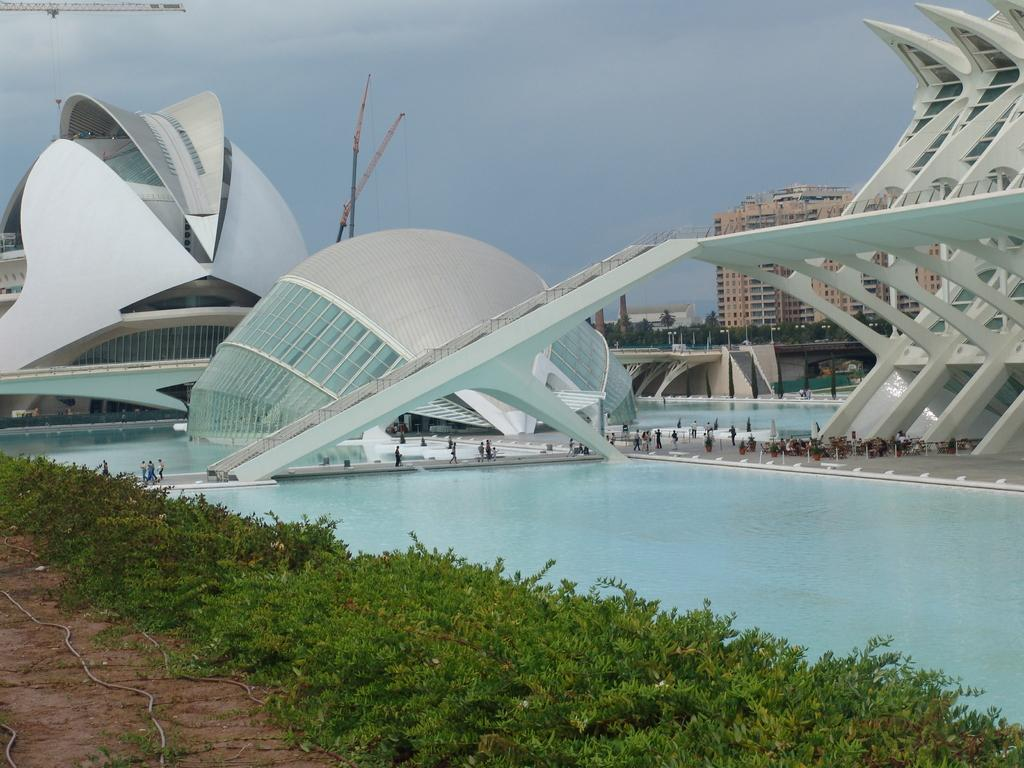What type of water feature can be seen in the image? There is a pool in the image. What kind of structures are visible in the image? The image contains beautiful architecture. What is located on the left side of the image? There is land on the left side of the image. What type of vegetation can be seen on the left side of the image? Plants are present on the left side of the image. What is the current debt situation of the plants on the left side of the image? There is no information about the debt situation of the plants in the image, as plants do not have debt. What type of hose is being used to water the plants on the left side of the image? There is no hose present in the image, as it only shows a pool, beautiful architecture, land, and plants. 